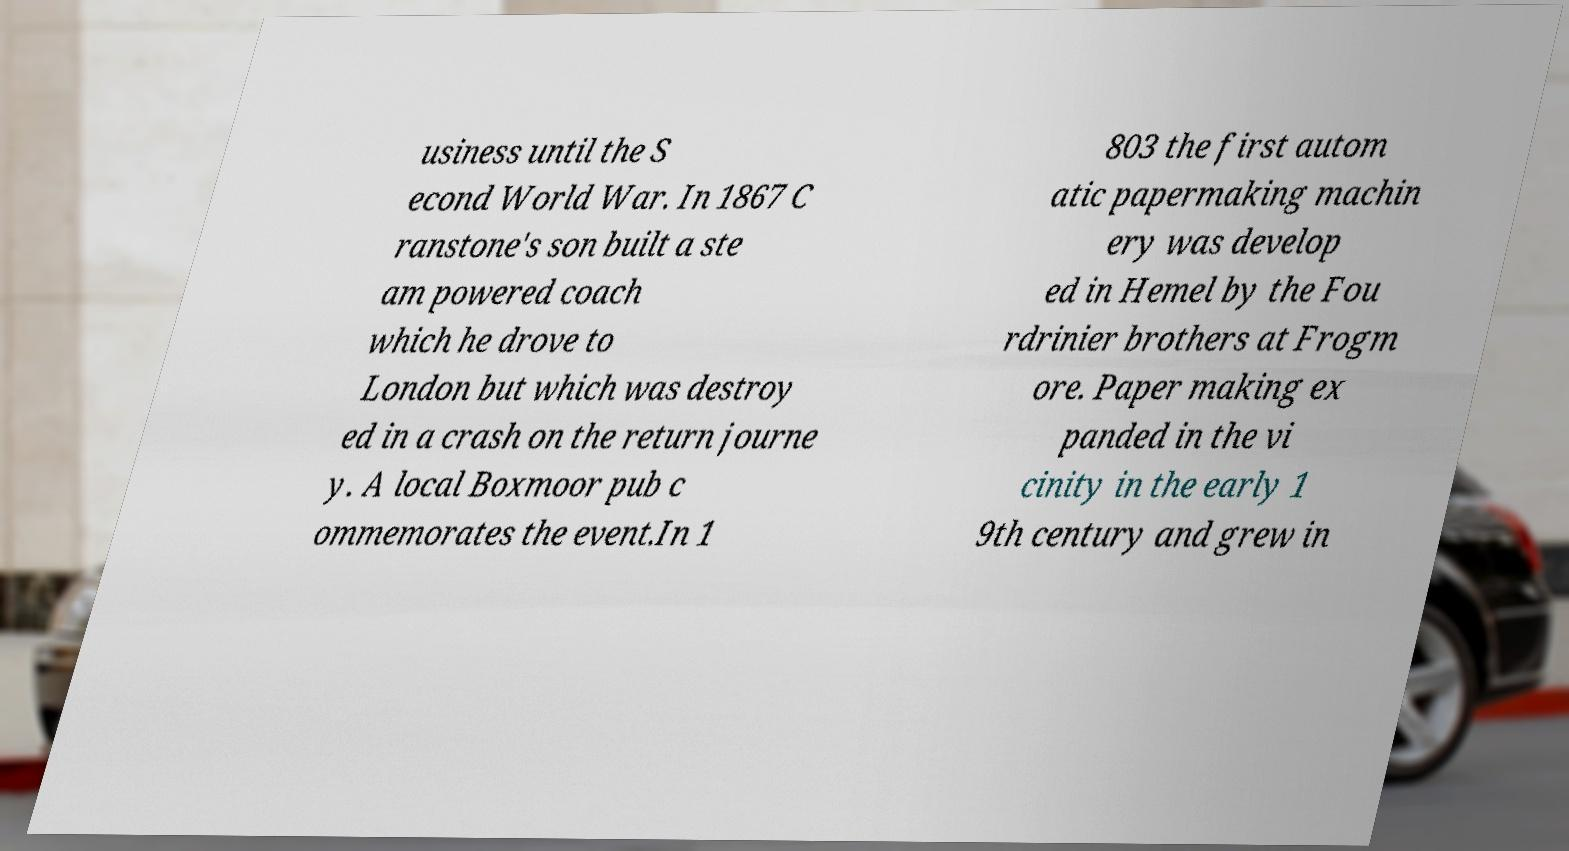For documentation purposes, I need the text within this image transcribed. Could you provide that? usiness until the S econd World War. In 1867 C ranstone's son built a ste am powered coach which he drove to London but which was destroy ed in a crash on the return journe y. A local Boxmoor pub c ommemorates the event.In 1 803 the first autom atic papermaking machin ery was develop ed in Hemel by the Fou rdrinier brothers at Frogm ore. Paper making ex panded in the vi cinity in the early 1 9th century and grew in 